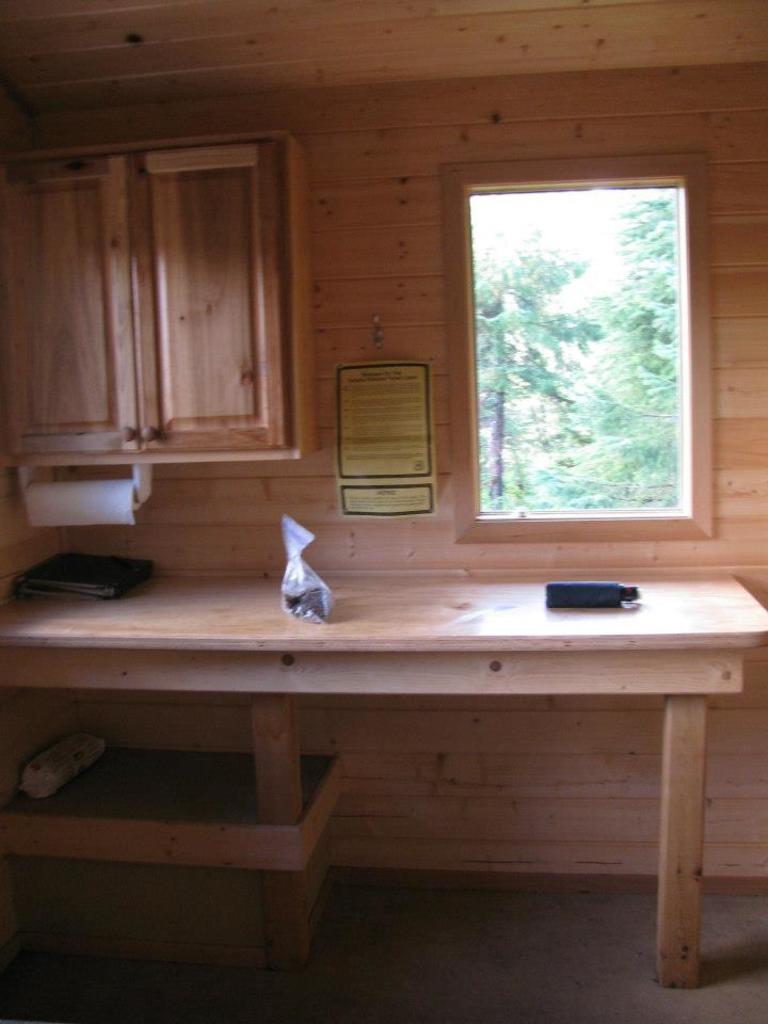Please provide a concise description of this image. In this image I can see some objects on the table. In the background, I can see the trees behind the window. I can also see the wall. 